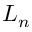Convert formula to latex. <formula><loc_0><loc_0><loc_500><loc_500>L _ { n }</formula> 